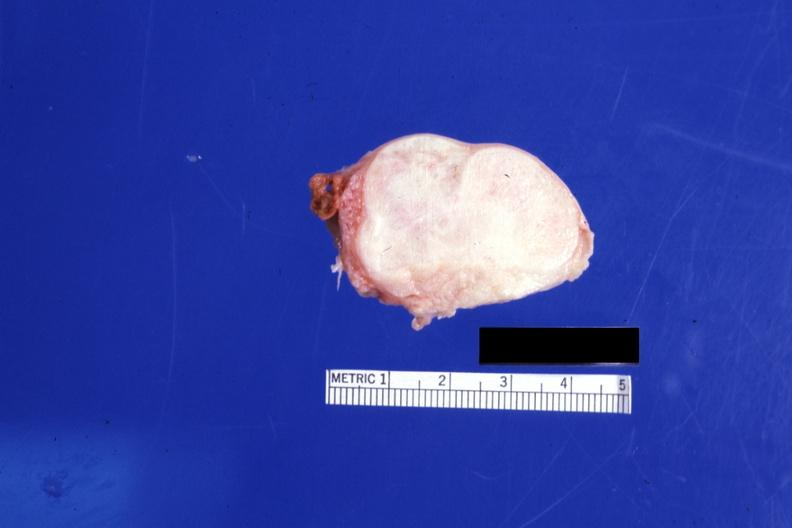s ovary present?
Answer the question using a single word or phrase. Yes 